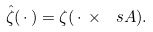<formula> <loc_0><loc_0><loc_500><loc_500>\hat { \zeta } ( \, \cdot \, ) = \zeta ( \, \cdot \, \times \ s A ) .</formula> 